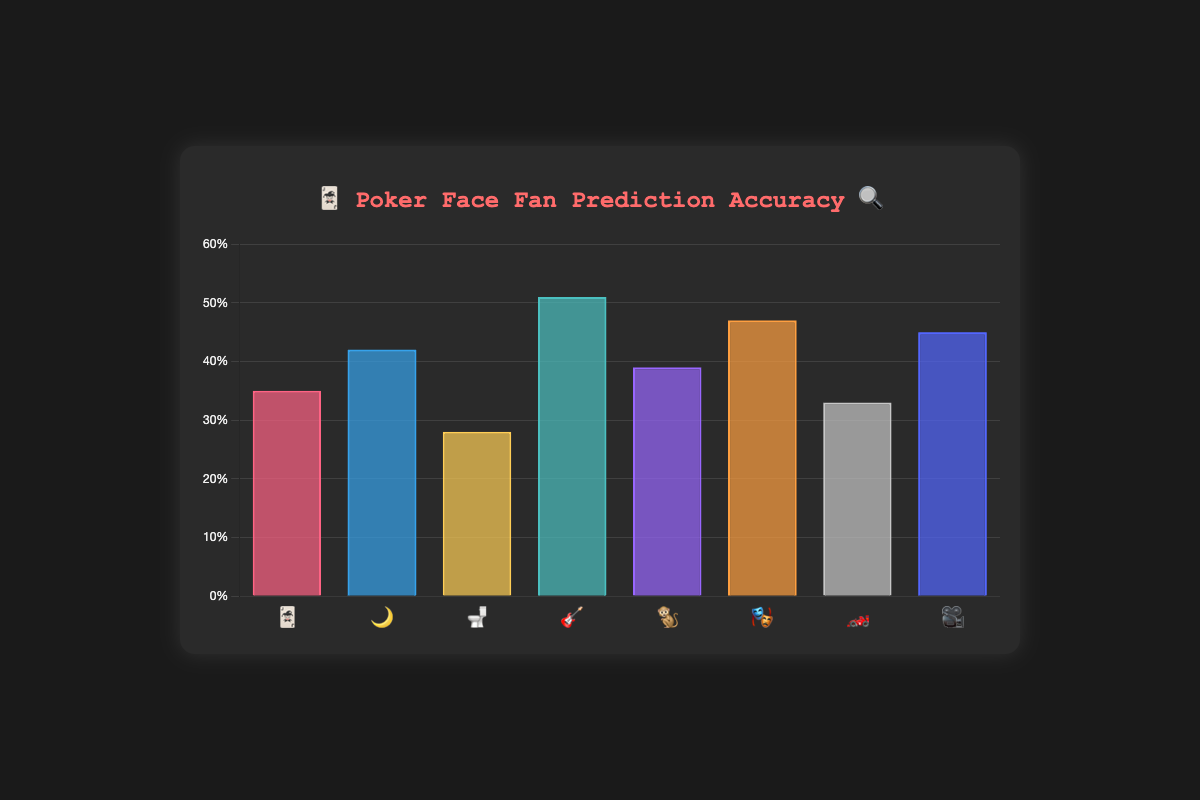Which episode had the highest fan prediction accuracy? By looking at the height of the bars, the tallest bar represents "Rest in Metal" with an accuracy of 51%.
Answer: "Rest in Metal" What is the average prediction accuracy across all episodes? Adding all the accuracies: 35 + 42 + 28 + 51 + 39 + 47 + 33 + 45 = 320. There are 8 episodes, so the average is 320/8 = 40%.
Answer: 40% Which episode had the lowest fan prediction accuracy? The shortest bar represents "The Stall" with an accuracy of 28%.
Answer: "The Stall" How much higher is the accuracy for "Rest in Metal" compared to "The Stall"? Subtract the accuracy of "The Stall" from the accuracy of "Rest in Metal": 51 - 28 = 23%.
Answer: 23% What is the total accuracy of the first four episodes? Add the accuracies of the first four episodes: 35 + 42 + 28 + 51 = 156%.
Answer: 156% How many episodes had an accuracy greater than 40%? The episodes with accuracy greater than 40% are "The Night Shift", "Rest in Metal", "Exit Stage Death", and "The Orpheus Syndrome", totaling 4 episodes.
Answer: 4 What emoji represents the episode with a 33% accuracy? Identifying the label with 33% accuracy, it's "🏎️".
Answer: 🏎️ Rank all episodes from lowest to highest in terms of prediction accuracy. Listing the accuracies in ascending order: "The Stall" (28%), "The Future of the Sport" (33%), "Dead Man's Hand" (35%), "Time of the Monkey" (39%), "The Night Shift" (42%), "The Orpheus Syndrome" (45%), "Exit Stage Death" (47%), "Rest in Metal" (51%).
Answer: "The Stall, The Future of the Sport, Dead Man's Hand, Time of the Monkey, The Night Shift, The Orpheus Syndrome, Exit Stage Death, Rest in Metal" What’s the difference between the highest and the lowest prediction accuracy? Subtract the lowest accuracy (28%) from the highest accuracy (51%): 51 - 28 = 23%.
Answer: 23% 